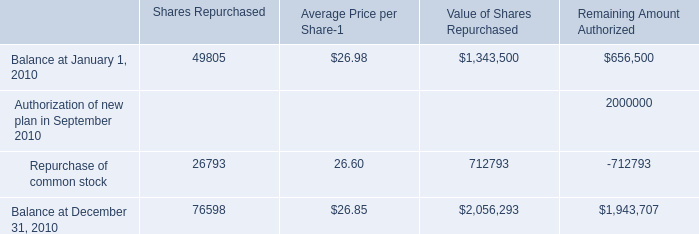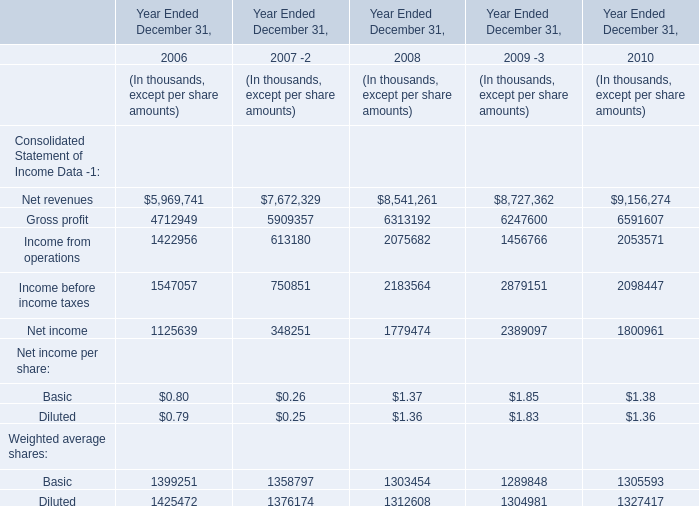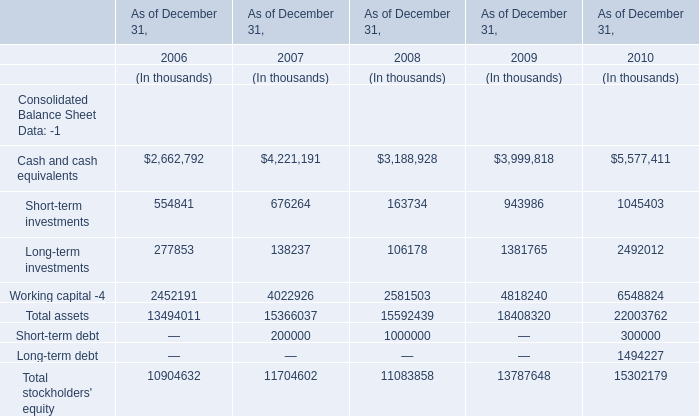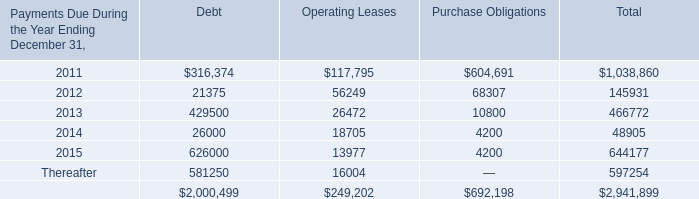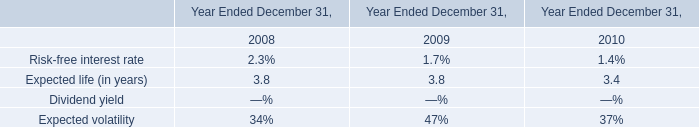In the year with largest amount of Cash and cash equivalents, what's the sum of Consolidated Balance Sheet Data? (in thousand) 
Computations: (((((((5577411 + 1045403) + 2492012) + 6548824) + 22003762) + 300000) + 1494227) + 15302179)
Answer: 54763818.0. 